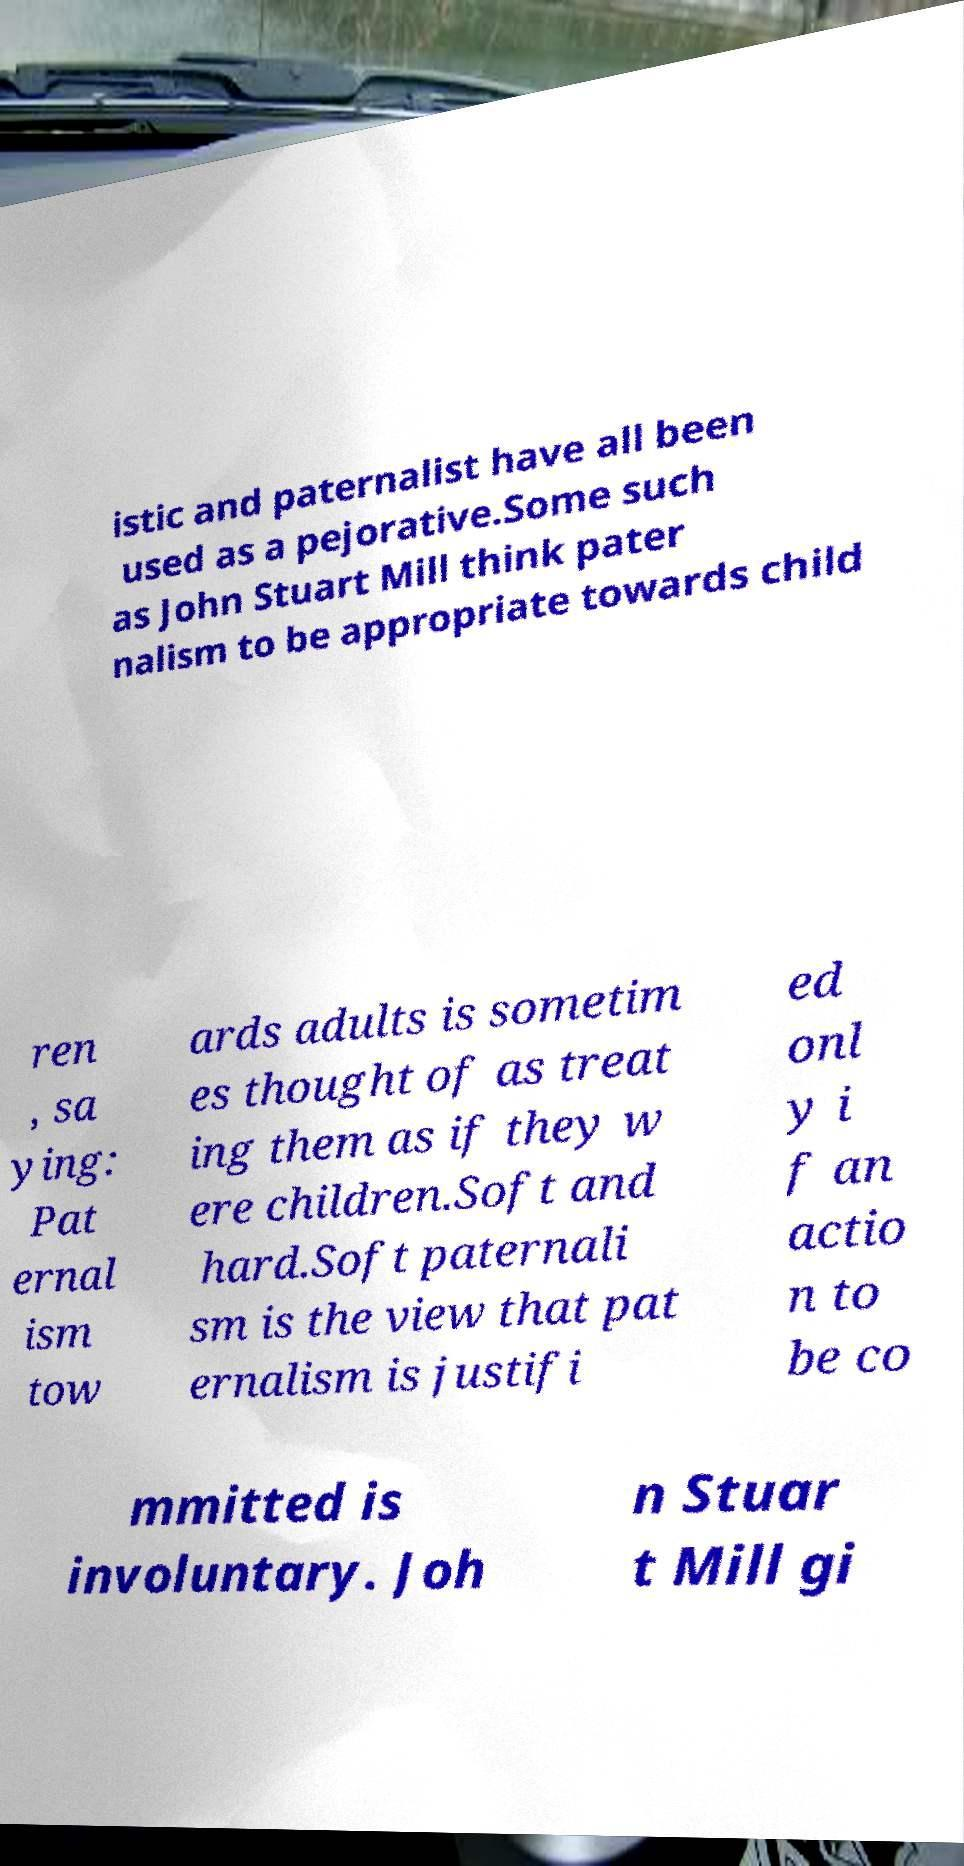Could you extract and type out the text from this image? istic and paternalist have all been used as a pejorative.Some such as John Stuart Mill think pater nalism to be appropriate towards child ren , sa ying: Pat ernal ism tow ards adults is sometim es thought of as treat ing them as if they w ere children.Soft and hard.Soft paternali sm is the view that pat ernalism is justifi ed onl y i f an actio n to be co mmitted is involuntary. Joh n Stuar t Mill gi 